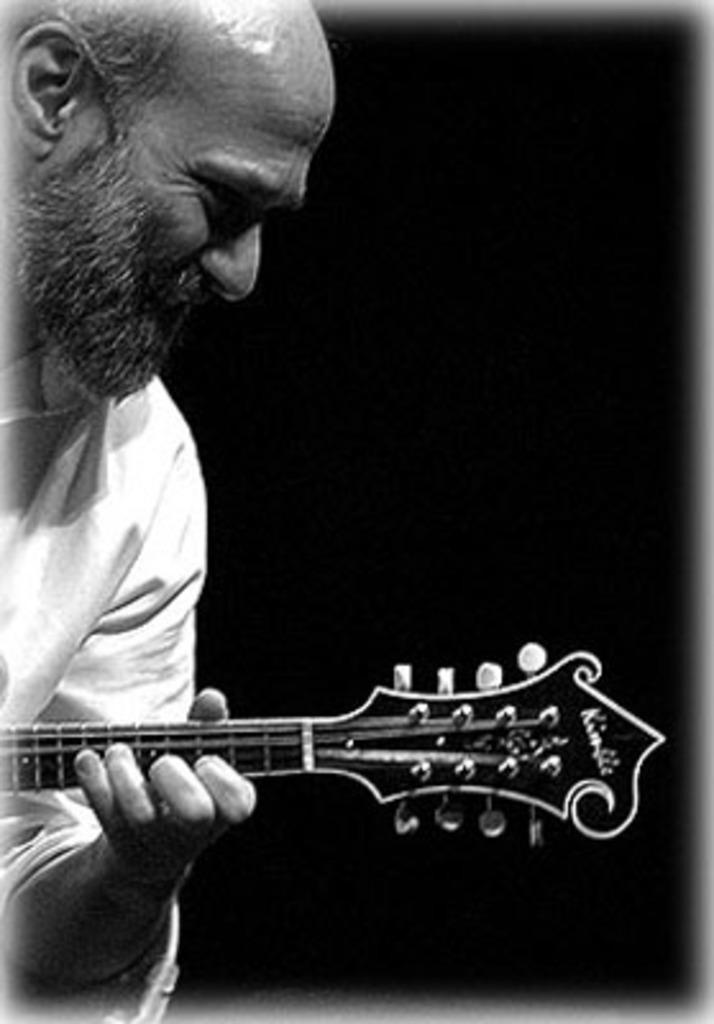What is present in the image? There is a man in the image. What is the man holding in the image? The man is holding a musical instrument. What type of tongue can be seen sticking out of the jar in the image? There is no jar or tongue present in the image. What type of apparatus is being used by the man in the image? The image only shows the man holding a musical instrument, and no apparatus is visible. 